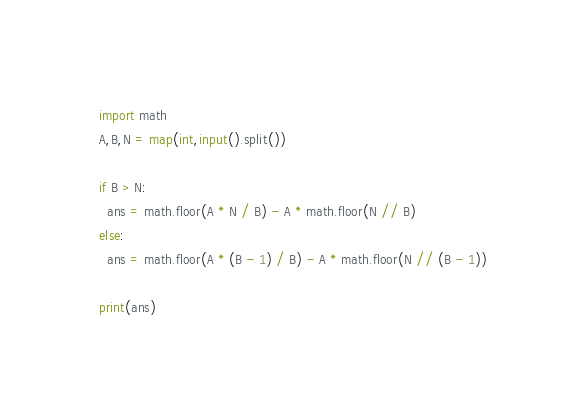<code> <loc_0><loc_0><loc_500><loc_500><_Python_>import math
A,B,N = map(int,input().split())

if B > N:
  ans = math.floor(A * N / B) - A * math.floor(N // B)
else:
  ans = math.floor(A * (B - 1) / B) - A * math.floor(N // (B - 1))
  
print(ans)</code> 